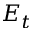<formula> <loc_0><loc_0><loc_500><loc_500>E _ { t }</formula> 